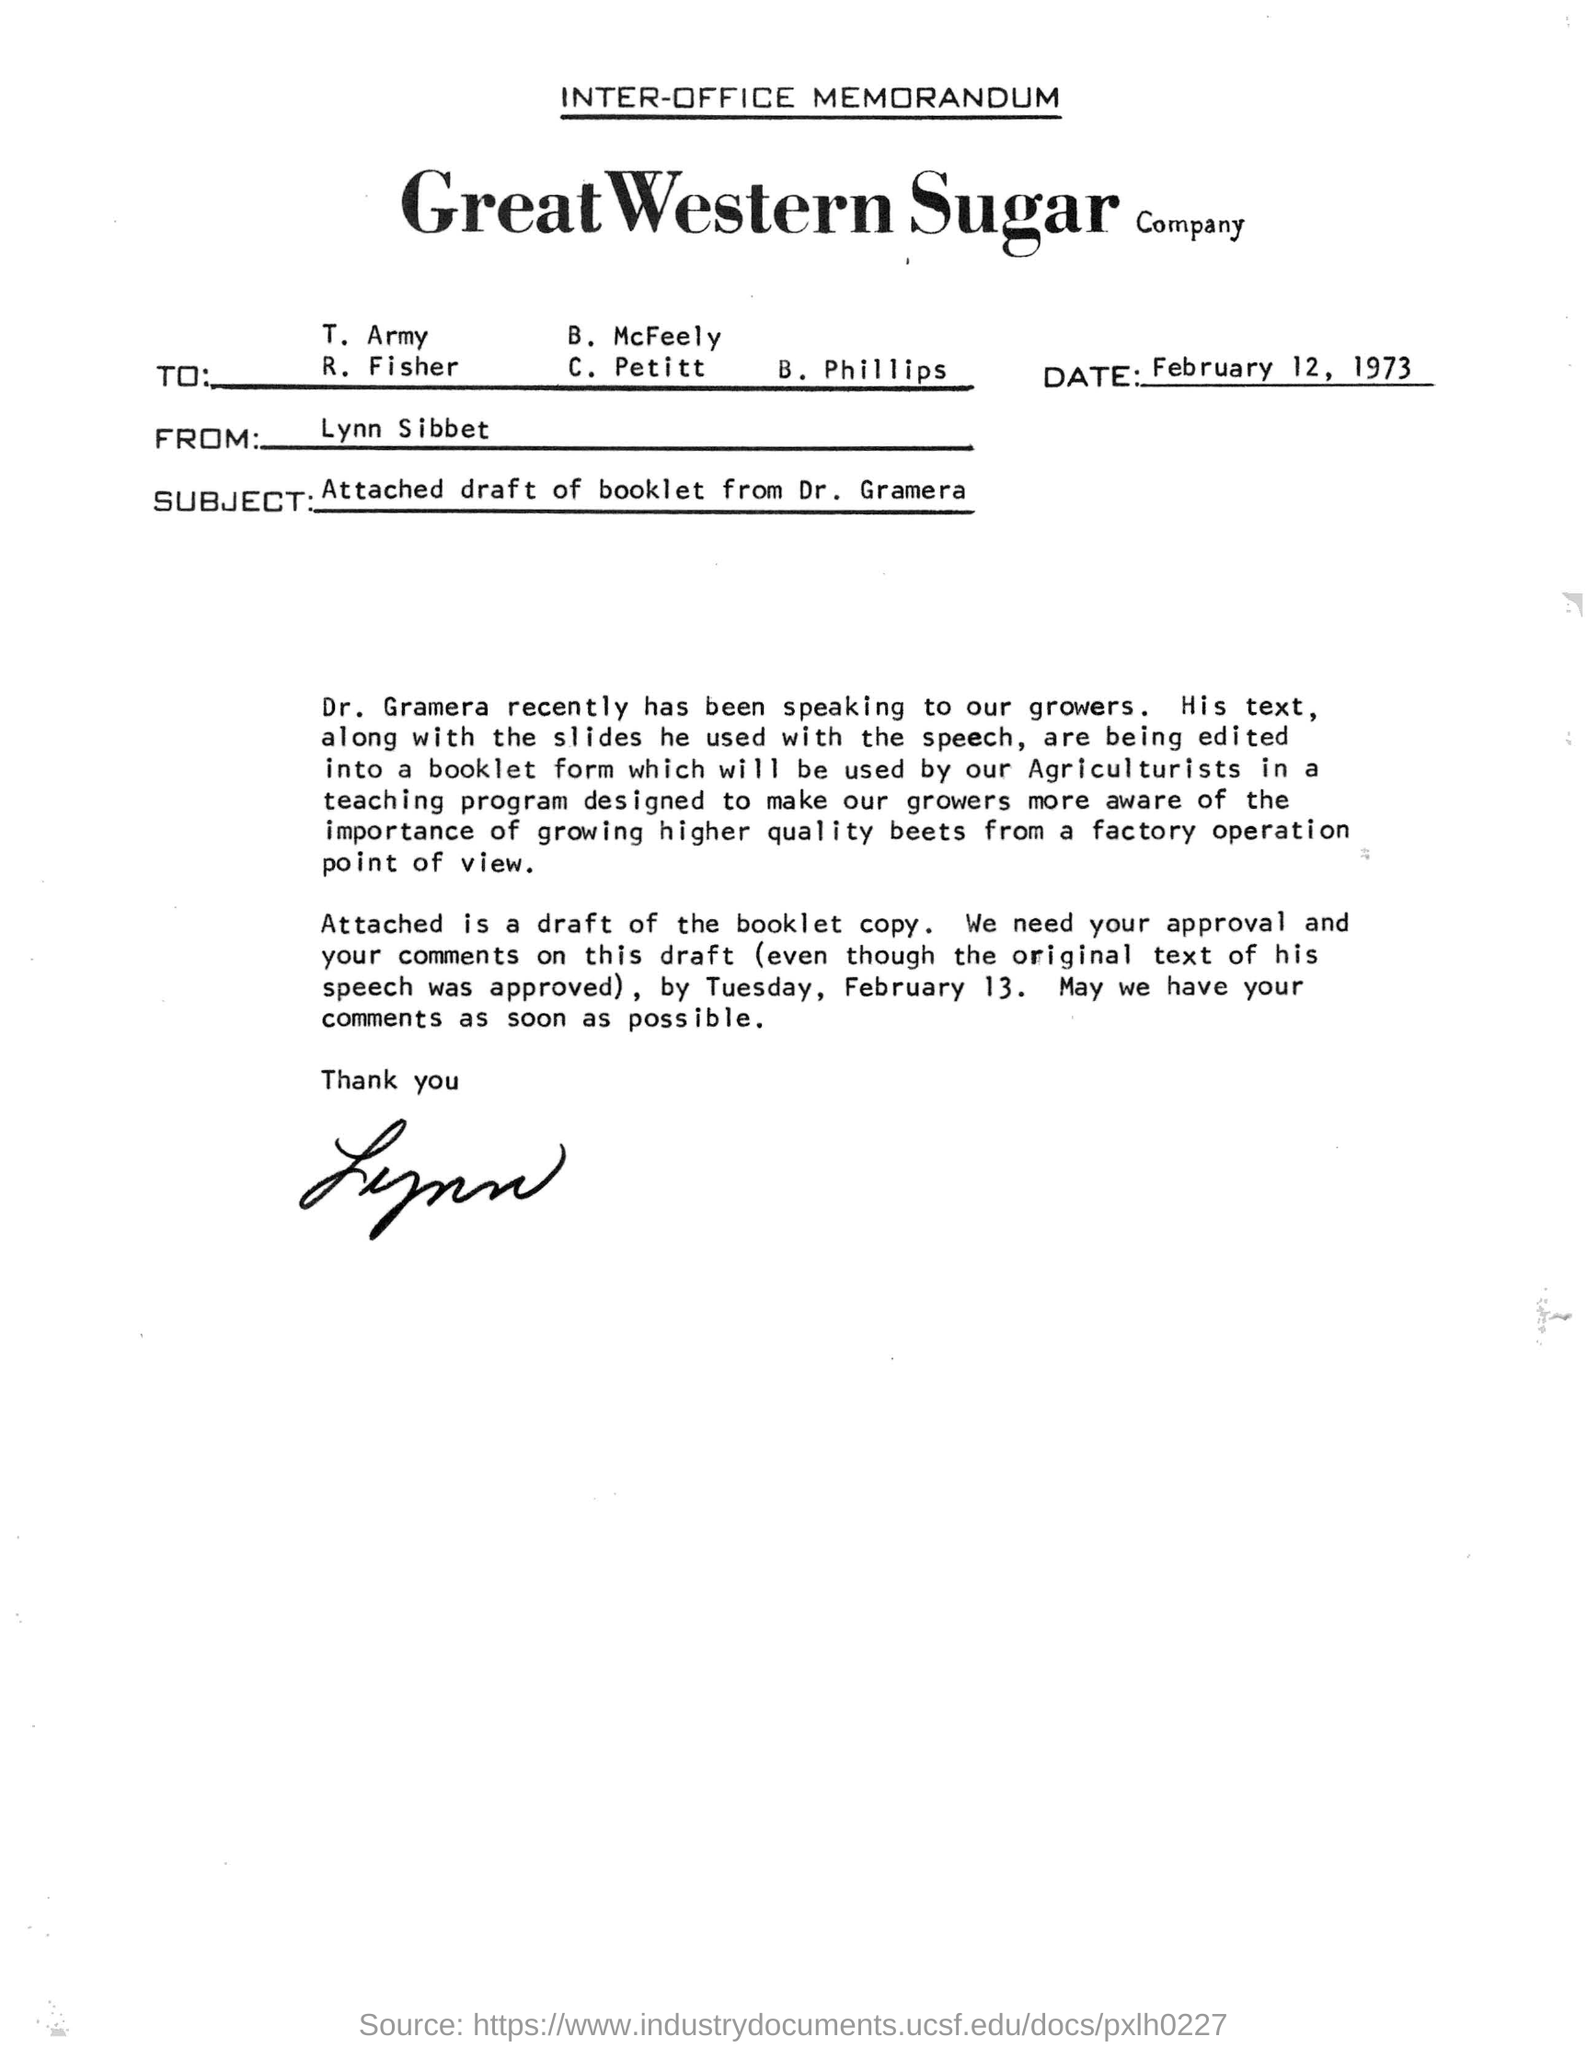Mention a couple of crucial points in this snapshot. The memorandum is from Lynn Sibbet. The date referenced in the memorandum is February 12, 1973. 